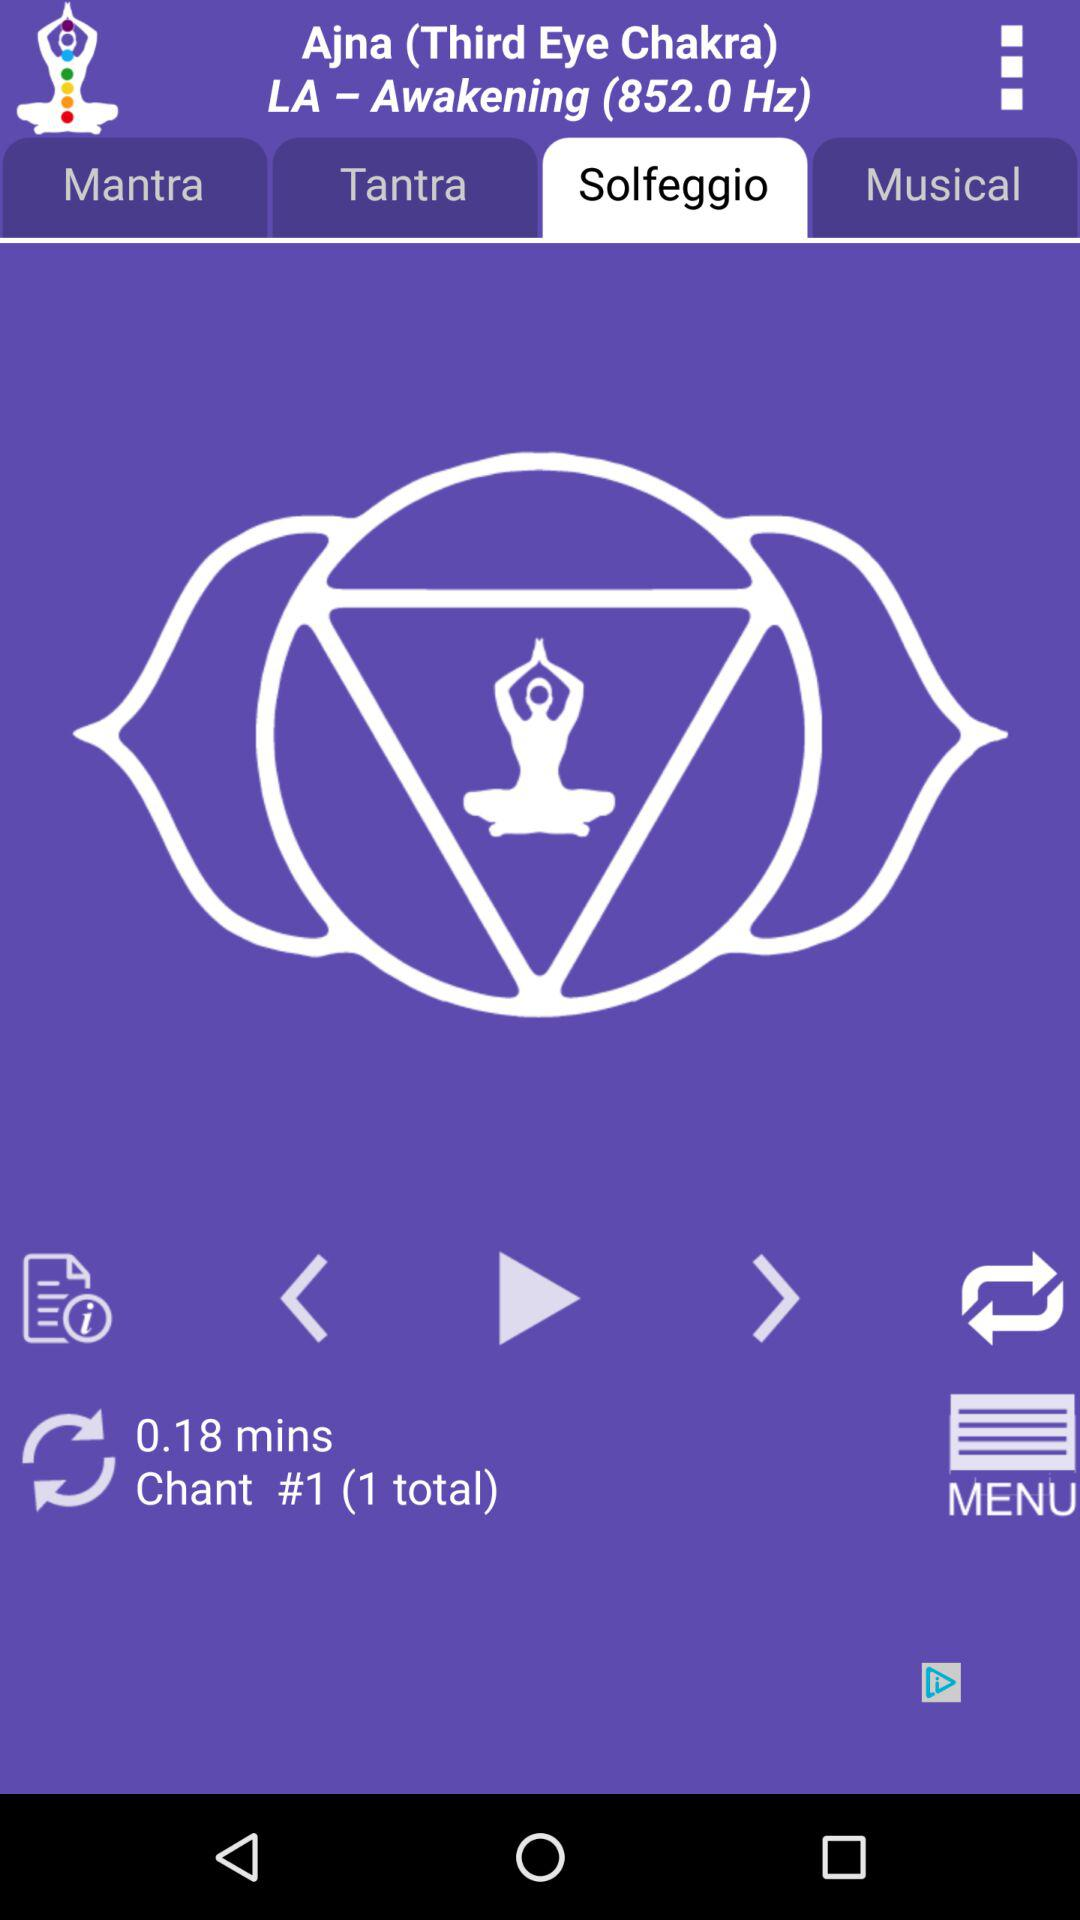What is the duration of Ajna? The duration is 0.18 minutes. 